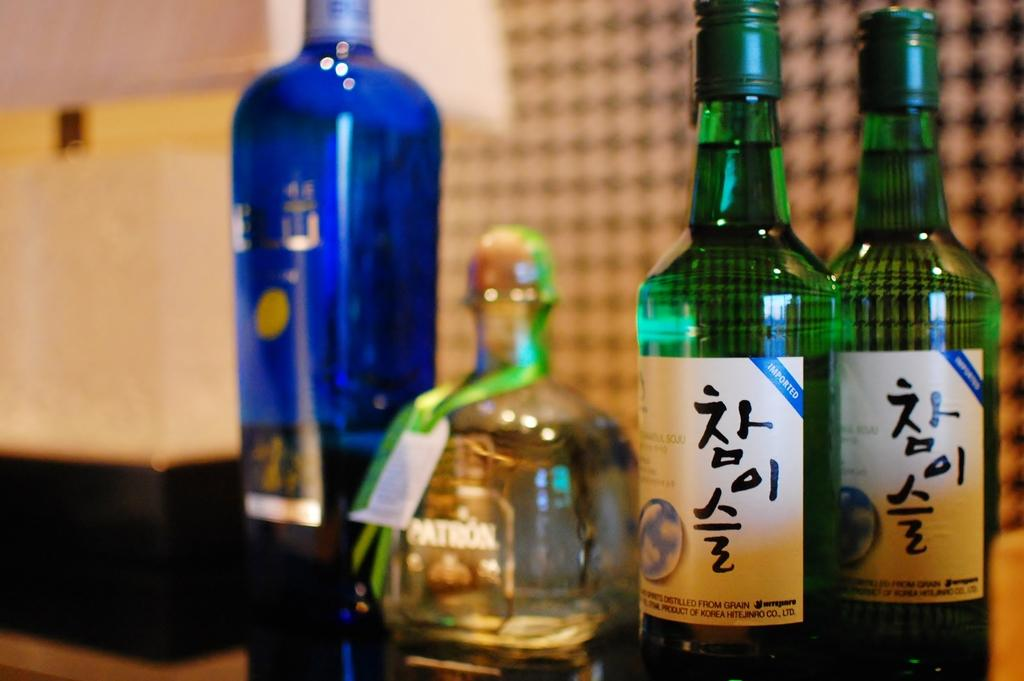Provide a one-sentence caption for the provided image. A bottle of Patron tequila is flanked by two tall green bottles and a blue bottle that are also full. 